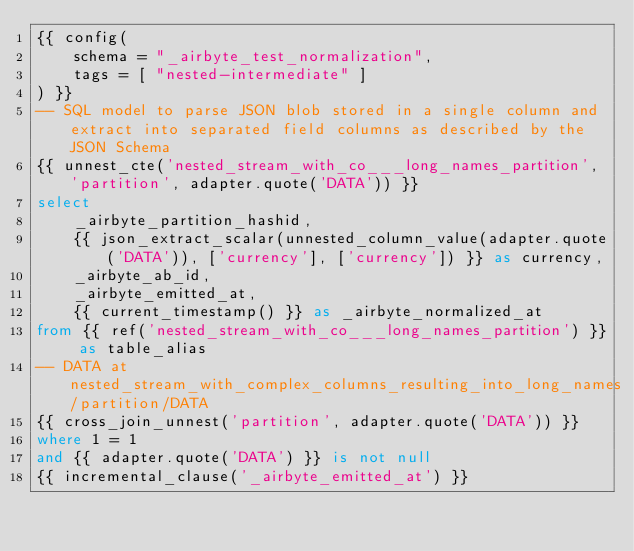<code> <loc_0><loc_0><loc_500><loc_500><_SQL_>{{ config(
    schema = "_airbyte_test_normalization",
    tags = [ "nested-intermediate" ]
) }}
-- SQL model to parse JSON blob stored in a single column and extract into separated field columns as described by the JSON Schema
{{ unnest_cte('nested_stream_with_co___long_names_partition', 'partition', adapter.quote('DATA')) }}
select
    _airbyte_partition_hashid,
    {{ json_extract_scalar(unnested_column_value(adapter.quote('DATA')), ['currency'], ['currency']) }} as currency,
    _airbyte_ab_id,
    _airbyte_emitted_at,
    {{ current_timestamp() }} as _airbyte_normalized_at
from {{ ref('nested_stream_with_co___long_names_partition') }} as table_alias
-- DATA at nested_stream_with_complex_columns_resulting_into_long_names/partition/DATA
{{ cross_join_unnest('partition', adapter.quote('DATA')) }}
where 1 = 1
and {{ adapter.quote('DATA') }} is not null
{{ incremental_clause('_airbyte_emitted_at') }}

</code> 